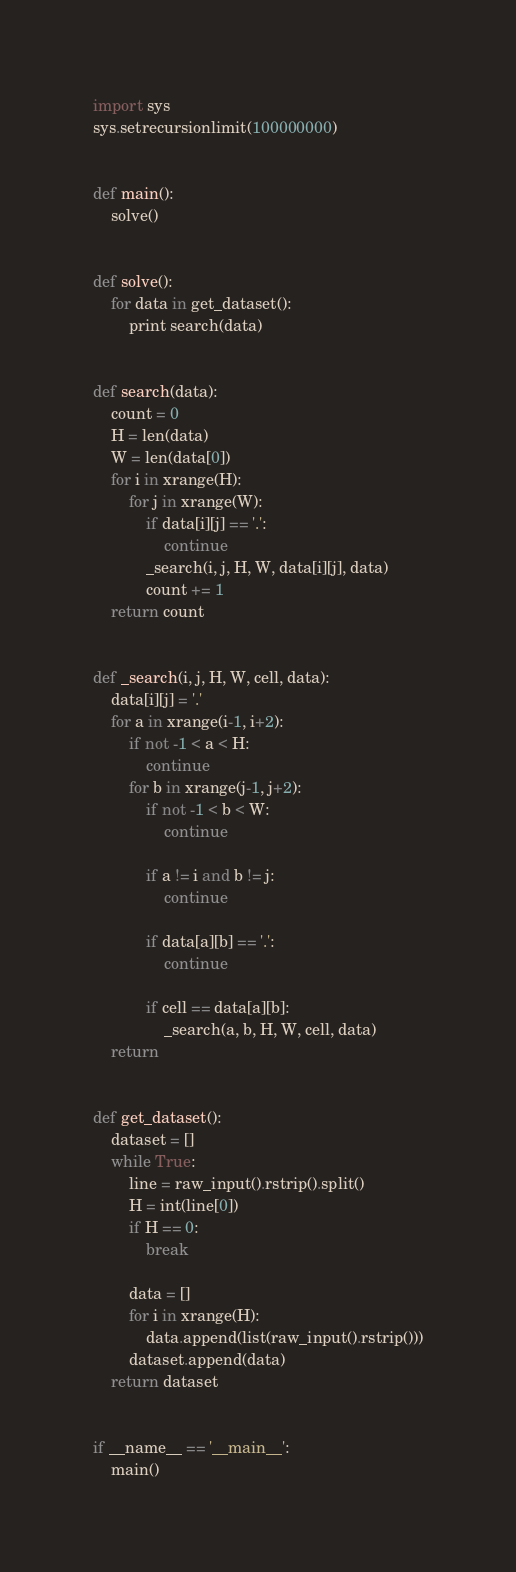<code> <loc_0><loc_0><loc_500><loc_500><_Python_>import sys
sys.setrecursionlimit(100000000)


def main():
    solve()


def solve():
    for data in get_dataset():
        print search(data)


def search(data):
    count = 0
    H = len(data)
    W = len(data[0])
    for i in xrange(H):
        for j in xrange(W):
            if data[i][j] == '.':
                continue
            _search(i, j, H, W, data[i][j], data)
            count += 1
    return count


def _search(i, j, H, W, cell, data):
    data[i][j] = '.'
    for a in xrange(i-1, i+2):
        if not -1 < a < H:
            continue
        for b in xrange(j-1, j+2):
            if not -1 < b < W:
                continue

            if a != i and b != j:
                continue

            if data[a][b] == '.':
                continue

            if cell == data[a][b]:
                _search(a, b, H, W, cell, data)
    return


def get_dataset():
    dataset = []
    while True:
        line = raw_input().rstrip().split()
        H = int(line[0])
        if H == 0:
            break

        data = []
        for i in xrange(H):
            data.append(list(raw_input().rstrip()))
        dataset.append(data)
    return dataset


if __name__ == '__main__':
    main()</code> 